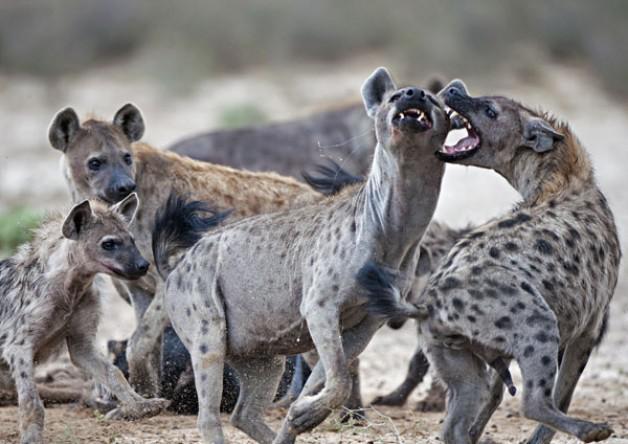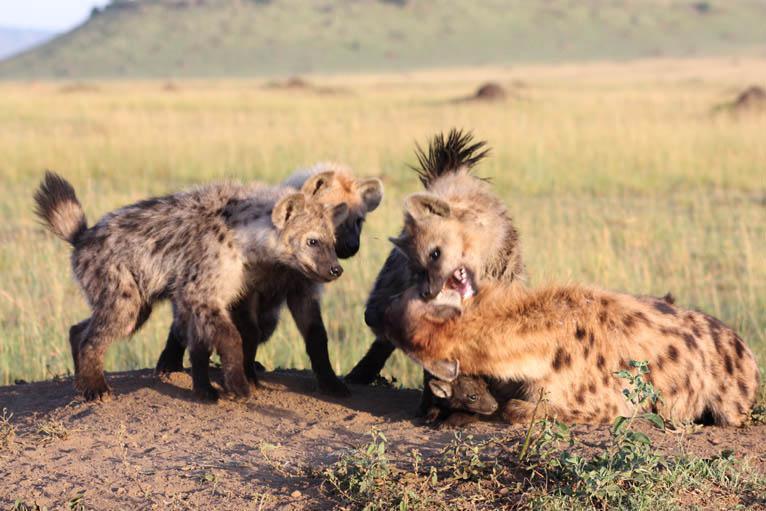The first image is the image on the left, the second image is the image on the right. For the images displayed, is the sentence "At least one image includes two hyenas fighting each other, with some bared fangs showing." factually correct? Answer yes or no. Yes. The first image is the image on the left, the second image is the image on the right. For the images shown, is this caption "There are atleast 4 Hyenas total" true? Answer yes or no. Yes. 